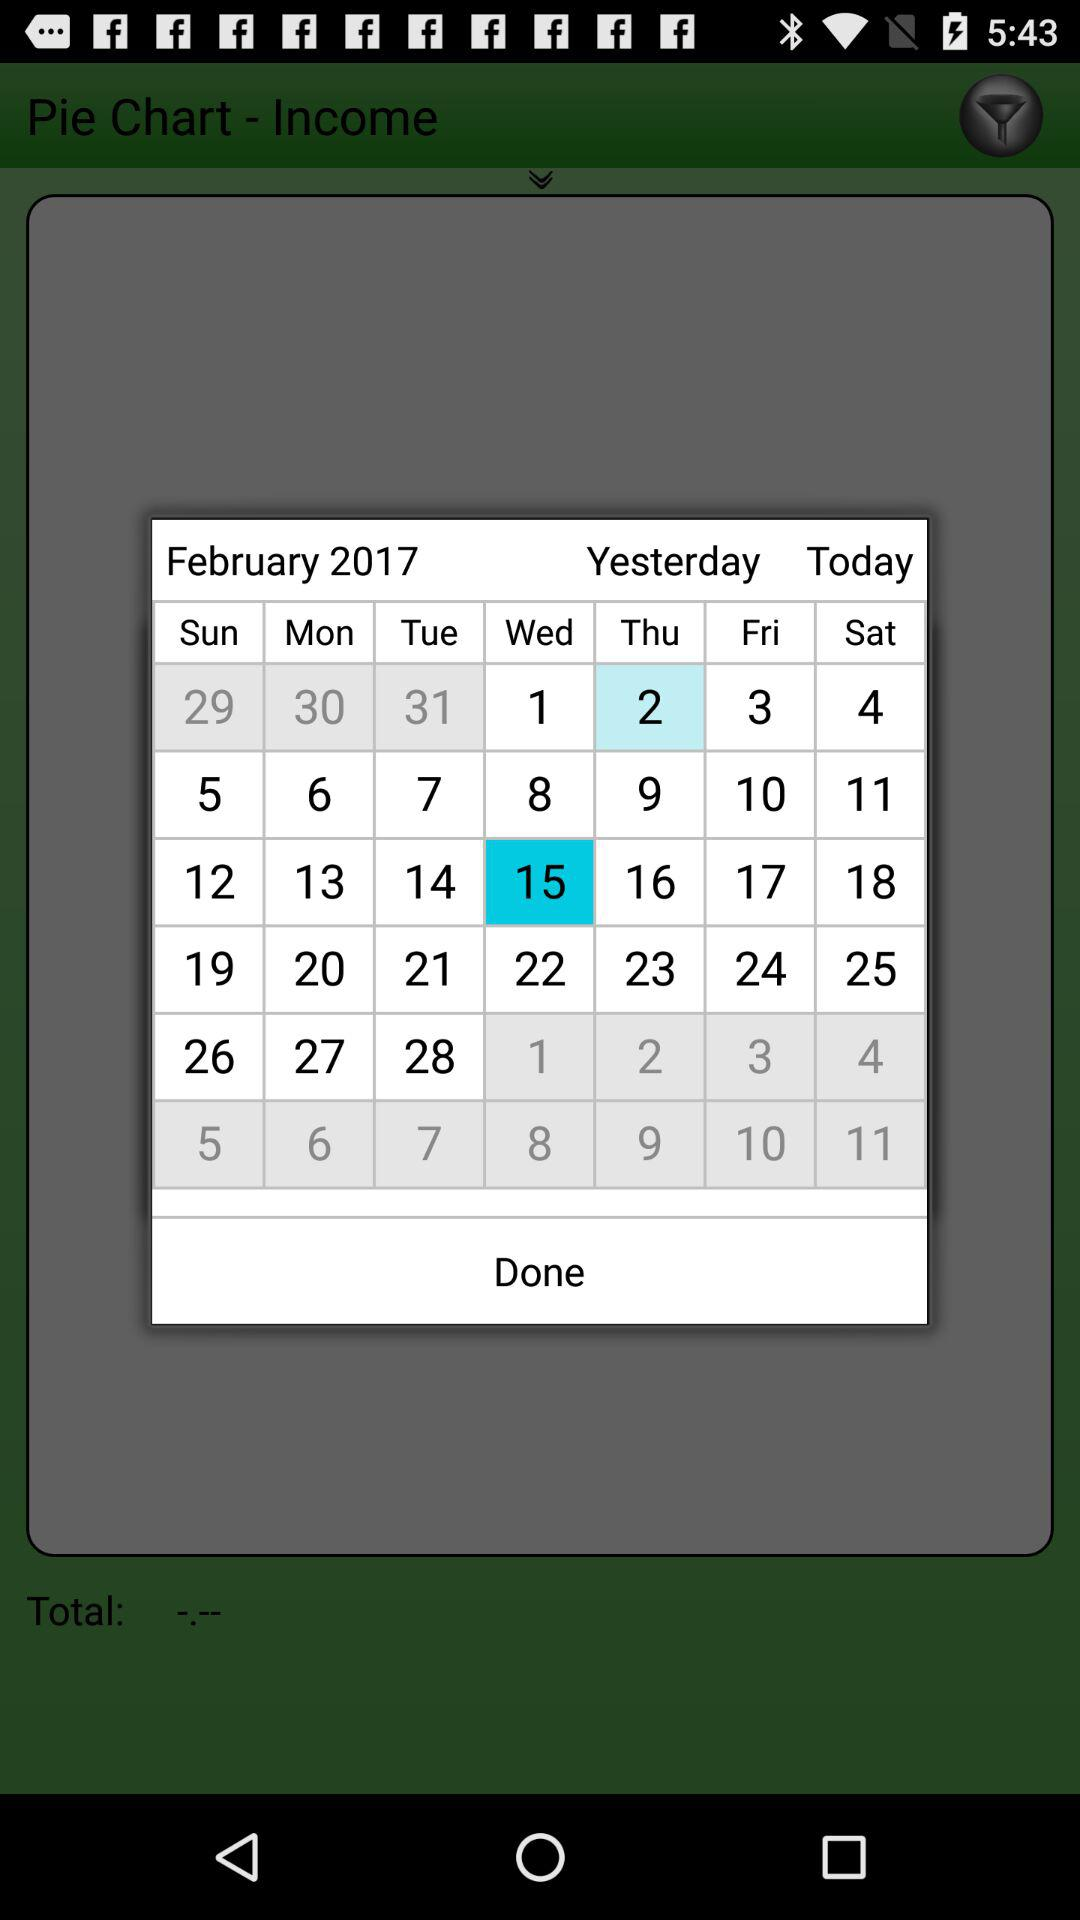How many dates are there in February 2017?
Answer the question using a single word or phrase. 28 